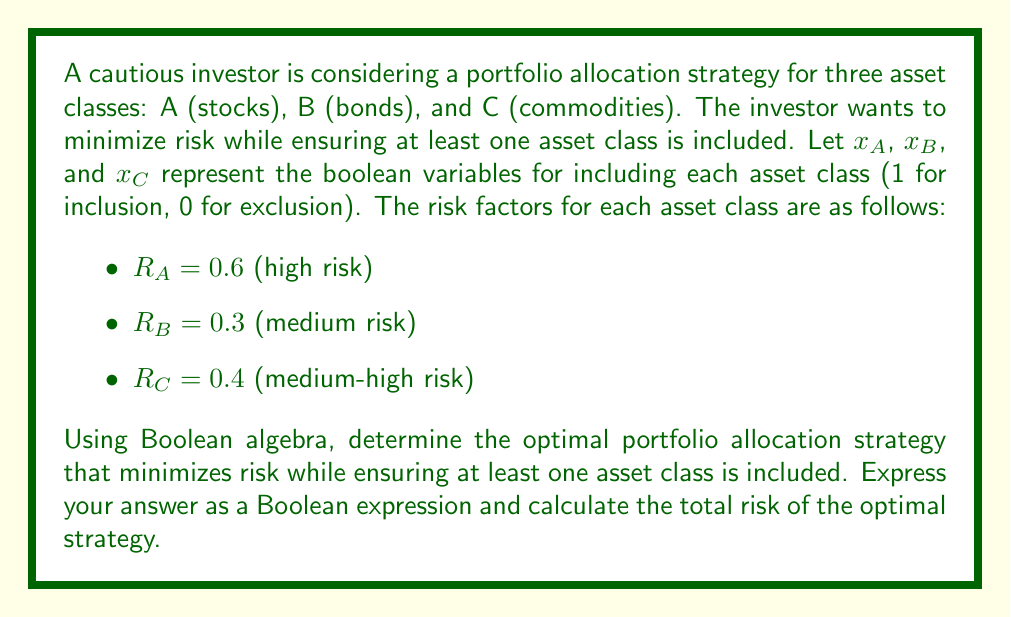What is the answer to this math problem? To solve this problem, we'll use Boolean algebra to minimize the risk while ensuring at least one asset class is included. We'll follow these steps:

1. Express the constraint that at least one asset class must be included:
   $$(x_A \lor x_B \lor x_C) = 1$$

2. Express the total risk as a Boolean function:
   $$R_{total} = 0.6x_A + 0.3x_B + 0.4x_C$$

3. To minimize risk, we need to find the combination with the lowest total risk that satisfies the constraint. We can do this by evaluating all possible combinations:

   $x_A = 1, x_B = 0, x_C = 0: R_{total} = 0.6$
   $x_A = 0, x_B = 1, x_C = 0: R_{total} = 0.3$
   $x_A = 0, x_B = 0, x_C = 1: R_{total} = 0.4$
   $x_A = 1, x_B = 1, x_C = 0: R_{total} = 0.9$
   $x_A = 1, x_B = 0, x_C = 1: R_{total} = 1.0$
   $x_A = 0, x_B = 1, x_C = 1: R_{total} = 0.7$
   $x_A = 1, x_B = 1, x_C = 1: R_{total} = 1.3$

4. The combination with the lowest risk that satisfies the constraint is $x_A = 0, x_B = 1, x_C = 0$.

5. We can express this as a Boolean expression:
   $$(\lnot x_A \land x_B \land \lnot x_C)$$

6. The total risk of this optimal strategy is 0.3.
Answer: The optimal portfolio allocation strategy can be expressed as the Boolean expression:
$$(\lnot x_A \land x_B \land \lnot x_C)$$
The total risk of the optimal strategy is 0.3. 